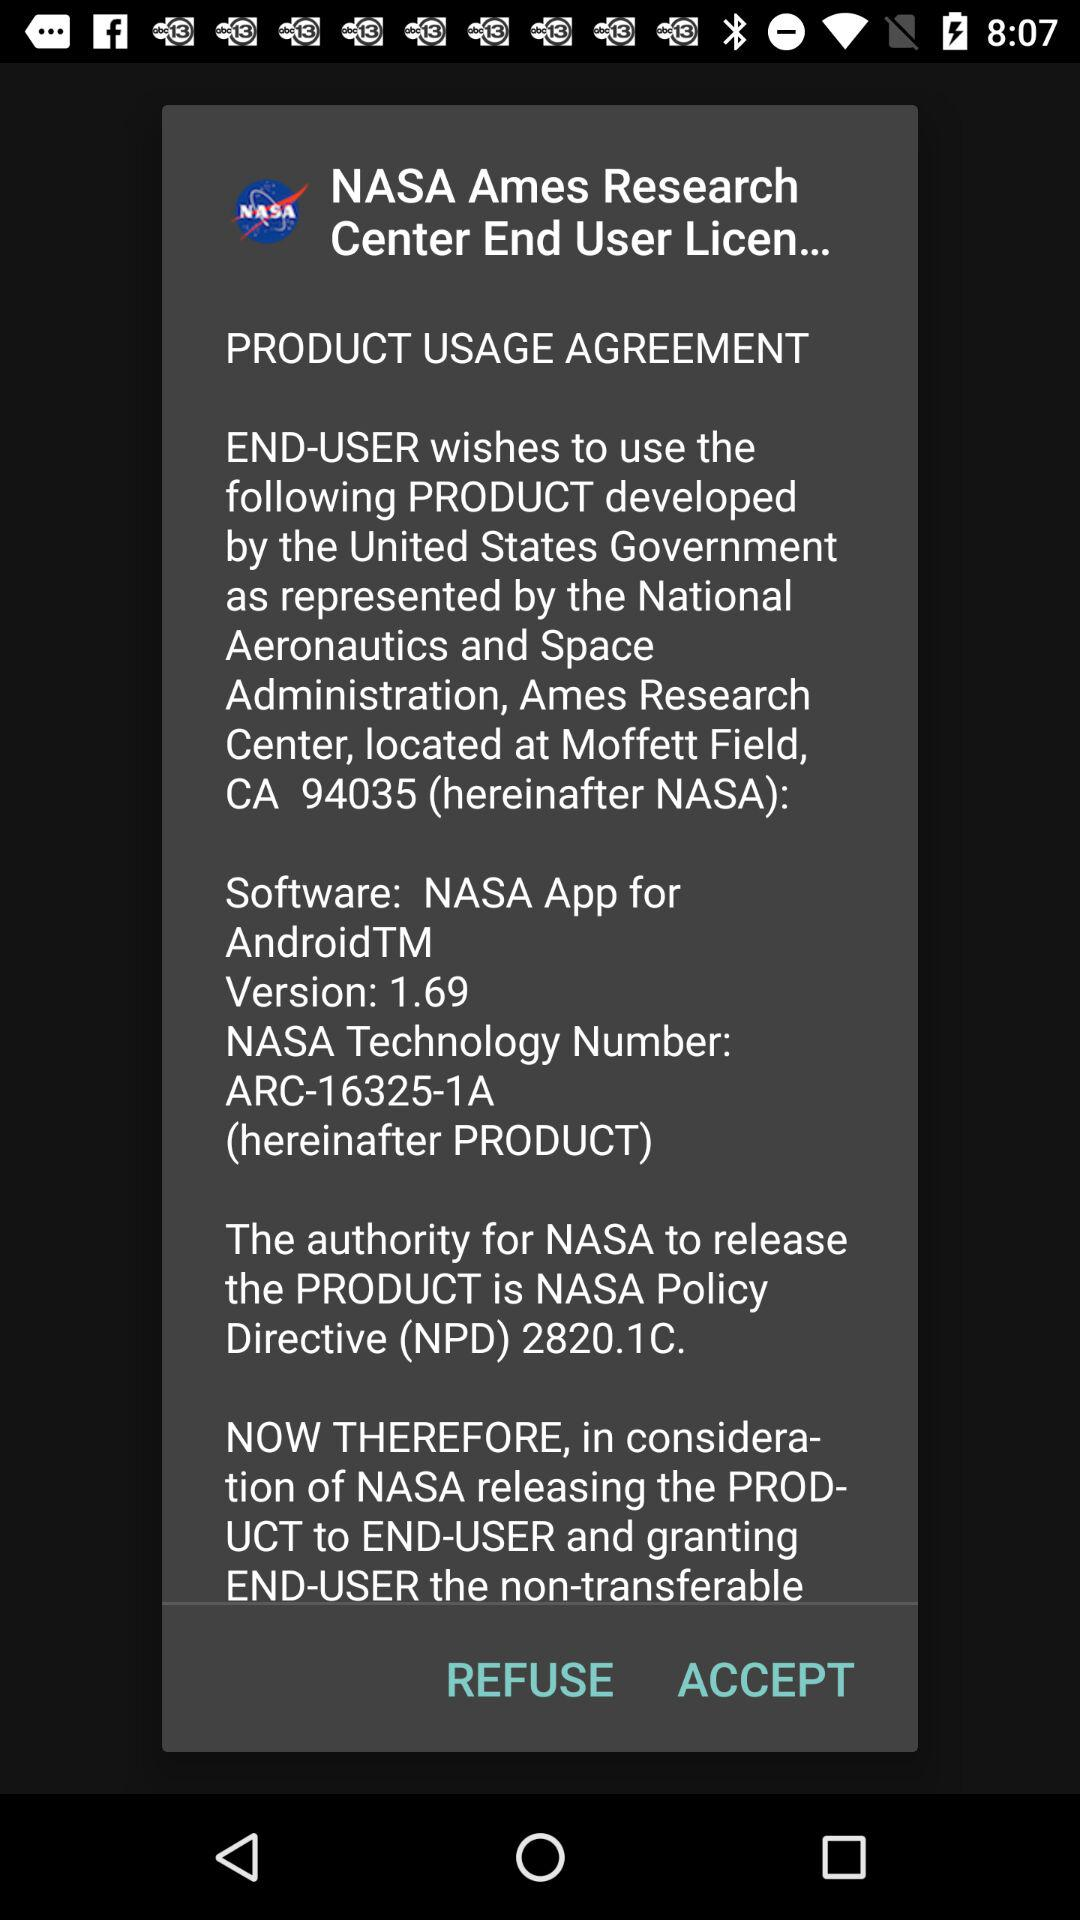Is "Accept" selected?
When the provided information is insufficient, respond with <no answer>. <no answer> 